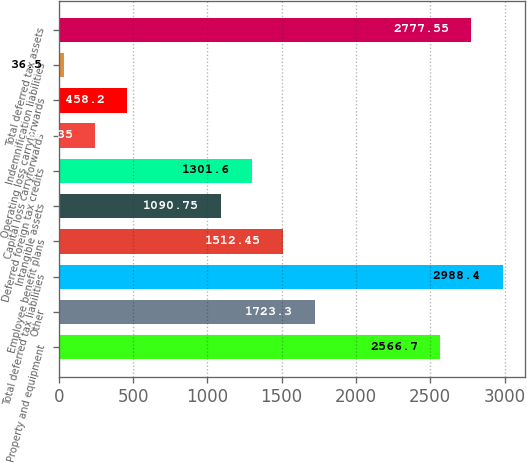<chart> <loc_0><loc_0><loc_500><loc_500><bar_chart><fcel>Property and equipment<fcel>Other<fcel>Total deferred tax liabilities<fcel>Employee benefit plans<fcel>Intangible assets<fcel>Deferred foreign tax credits<fcel>Capital loss carryforwards<fcel>Operating loss carryforwards<fcel>Indemnification liabilities<fcel>Total deferred tax assets<nl><fcel>2566.7<fcel>1723.3<fcel>2988.4<fcel>1512.45<fcel>1090.75<fcel>1301.6<fcel>247.35<fcel>458.2<fcel>36.5<fcel>2777.55<nl></chart> 